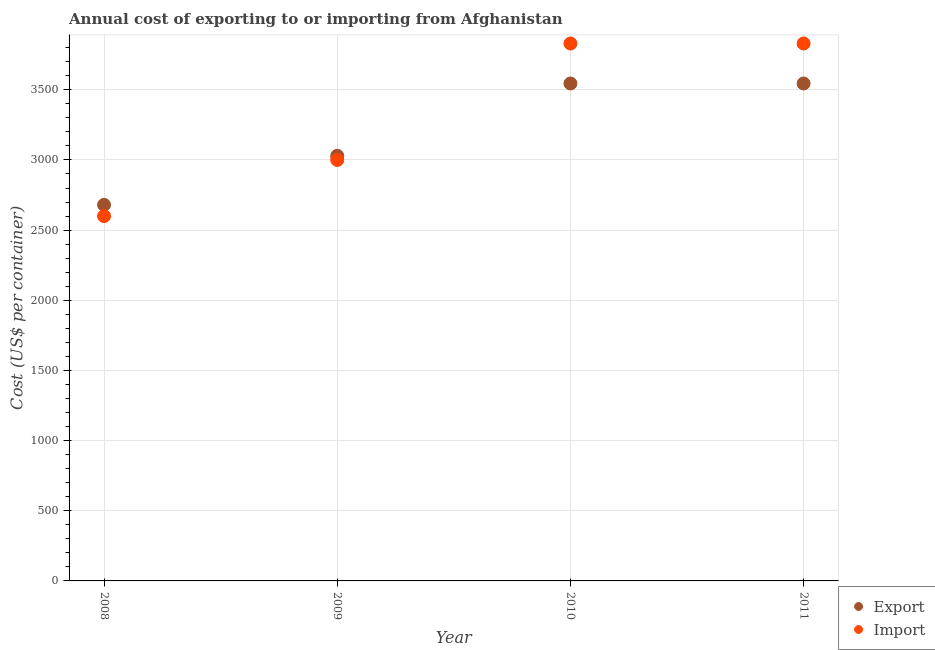How many different coloured dotlines are there?
Offer a terse response. 2. Is the number of dotlines equal to the number of legend labels?
Provide a succinct answer. Yes. What is the import cost in 2011?
Offer a very short reply. 3830. Across all years, what is the maximum export cost?
Keep it short and to the point. 3545. Across all years, what is the minimum export cost?
Your response must be concise. 2680. In which year was the export cost minimum?
Make the answer very short. 2008. What is the total export cost in the graph?
Offer a very short reply. 1.28e+04. What is the difference between the export cost in 2008 and that in 2009?
Provide a succinct answer. -350. What is the difference between the import cost in 2011 and the export cost in 2009?
Make the answer very short. 800. What is the average export cost per year?
Provide a succinct answer. 3200. In the year 2009, what is the difference between the export cost and import cost?
Keep it short and to the point. 30. In how many years, is the export cost greater than 2100 US$?
Offer a very short reply. 4. What is the ratio of the export cost in 2009 to that in 2011?
Provide a succinct answer. 0.85. Is the export cost in 2009 less than that in 2011?
Keep it short and to the point. Yes. What is the difference between the highest and the lowest export cost?
Provide a short and direct response. 865. In how many years, is the import cost greater than the average import cost taken over all years?
Your response must be concise. 2. Is the sum of the import cost in 2008 and 2010 greater than the maximum export cost across all years?
Ensure brevity in your answer.  Yes. Does the import cost monotonically increase over the years?
Your response must be concise. No. What is the difference between two consecutive major ticks on the Y-axis?
Offer a very short reply. 500. Does the graph contain grids?
Provide a succinct answer. Yes. Where does the legend appear in the graph?
Keep it short and to the point. Bottom right. How are the legend labels stacked?
Provide a succinct answer. Vertical. What is the title of the graph?
Offer a terse response. Annual cost of exporting to or importing from Afghanistan. Does "Death rate" appear as one of the legend labels in the graph?
Your answer should be compact. No. What is the label or title of the X-axis?
Make the answer very short. Year. What is the label or title of the Y-axis?
Your answer should be compact. Cost (US$ per container). What is the Cost (US$ per container) in Export in 2008?
Your answer should be very brief. 2680. What is the Cost (US$ per container) in Import in 2008?
Your answer should be very brief. 2600. What is the Cost (US$ per container) of Export in 2009?
Make the answer very short. 3030. What is the Cost (US$ per container) of Import in 2009?
Keep it short and to the point. 3000. What is the Cost (US$ per container) of Export in 2010?
Ensure brevity in your answer.  3545. What is the Cost (US$ per container) of Import in 2010?
Ensure brevity in your answer.  3830. What is the Cost (US$ per container) in Export in 2011?
Offer a terse response. 3545. What is the Cost (US$ per container) in Import in 2011?
Your response must be concise. 3830. Across all years, what is the maximum Cost (US$ per container) of Export?
Your response must be concise. 3545. Across all years, what is the maximum Cost (US$ per container) in Import?
Give a very brief answer. 3830. Across all years, what is the minimum Cost (US$ per container) in Export?
Ensure brevity in your answer.  2680. Across all years, what is the minimum Cost (US$ per container) of Import?
Your answer should be compact. 2600. What is the total Cost (US$ per container) in Export in the graph?
Your answer should be very brief. 1.28e+04. What is the total Cost (US$ per container) in Import in the graph?
Keep it short and to the point. 1.33e+04. What is the difference between the Cost (US$ per container) in Export in 2008 and that in 2009?
Provide a short and direct response. -350. What is the difference between the Cost (US$ per container) in Import in 2008 and that in 2009?
Provide a short and direct response. -400. What is the difference between the Cost (US$ per container) in Export in 2008 and that in 2010?
Offer a terse response. -865. What is the difference between the Cost (US$ per container) of Import in 2008 and that in 2010?
Provide a short and direct response. -1230. What is the difference between the Cost (US$ per container) in Export in 2008 and that in 2011?
Offer a very short reply. -865. What is the difference between the Cost (US$ per container) in Import in 2008 and that in 2011?
Your response must be concise. -1230. What is the difference between the Cost (US$ per container) of Export in 2009 and that in 2010?
Make the answer very short. -515. What is the difference between the Cost (US$ per container) of Import in 2009 and that in 2010?
Offer a terse response. -830. What is the difference between the Cost (US$ per container) of Export in 2009 and that in 2011?
Provide a short and direct response. -515. What is the difference between the Cost (US$ per container) of Import in 2009 and that in 2011?
Make the answer very short. -830. What is the difference between the Cost (US$ per container) in Import in 2010 and that in 2011?
Your response must be concise. 0. What is the difference between the Cost (US$ per container) of Export in 2008 and the Cost (US$ per container) of Import in 2009?
Your response must be concise. -320. What is the difference between the Cost (US$ per container) in Export in 2008 and the Cost (US$ per container) in Import in 2010?
Your response must be concise. -1150. What is the difference between the Cost (US$ per container) in Export in 2008 and the Cost (US$ per container) in Import in 2011?
Keep it short and to the point. -1150. What is the difference between the Cost (US$ per container) in Export in 2009 and the Cost (US$ per container) in Import in 2010?
Ensure brevity in your answer.  -800. What is the difference between the Cost (US$ per container) of Export in 2009 and the Cost (US$ per container) of Import in 2011?
Offer a very short reply. -800. What is the difference between the Cost (US$ per container) of Export in 2010 and the Cost (US$ per container) of Import in 2011?
Provide a succinct answer. -285. What is the average Cost (US$ per container) in Export per year?
Provide a succinct answer. 3200. What is the average Cost (US$ per container) of Import per year?
Ensure brevity in your answer.  3315. In the year 2010, what is the difference between the Cost (US$ per container) of Export and Cost (US$ per container) of Import?
Your answer should be compact. -285. In the year 2011, what is the difference between the Cost (US$ per container) in Export and Cost (US$ per container) in Import?
Offer a very short reply. -285. What is the ratio of the Cost (US$ per container) of Export in 2008 to that in 2009?
Provide a short and direct response. 0.88. What is the ratio of the Cost (US$ per container) in Import in 2008 to that in 2009?
Make the answer very short. 0.87. What is the ratio of the Cost (US$ per container) in Export in 2008 to that in 2010?
Make the answer very short. 0.76. What is the ratio of the Cost (US$ per container) in Import in 2008 to that in 2010?
Your answer should be very brief. 0.68. What is the ratio of the Cost (US$ per container) in Export in 2008 to that in 2011?
Your answer should be very brief. 0.76. What is the ratio of the Cost (US$ per container) of Import in 2008 to that in 2011?
Provide a short and direct response. 0.68. What is the ratio of the Cost (US$ per container) in Export in 2009 to that in 2010?
Provide a succinct answer. 0.85. What is the ratio of the Cost (US$ per container) of Import in 2009 to that in 2010?
Your answer should be very brief. 0.78. What is the ratio of the Cost (US$ per container) in Export in 2009 to that in 2011?
Make the answer very short. 0.85. What is the ratio of the Cost (US$ per container) in Import in 2009 to that in 2011?
Offer a very short reply. 0.78. What is the ratio of the Cost (US$ per container) of Export in 2010 to that in 2011?
Offer a very short reply. 1. What is the ratio of the Cost (US$ per container) in Import in 2010 to that in 2011?
Give a very brief answer. 1. What is the difference between the highest and the second highest Cost (US$ per container) in Export?
Provide a succinct answer. 0. What is the difference between the highest and the lowest Cost (US$ per container) in Export?
Offer a terse response. 865. What is the difference between the highest and the lowest Cost (US$ per container) in Import?
Give a very brief answer. 1230. 